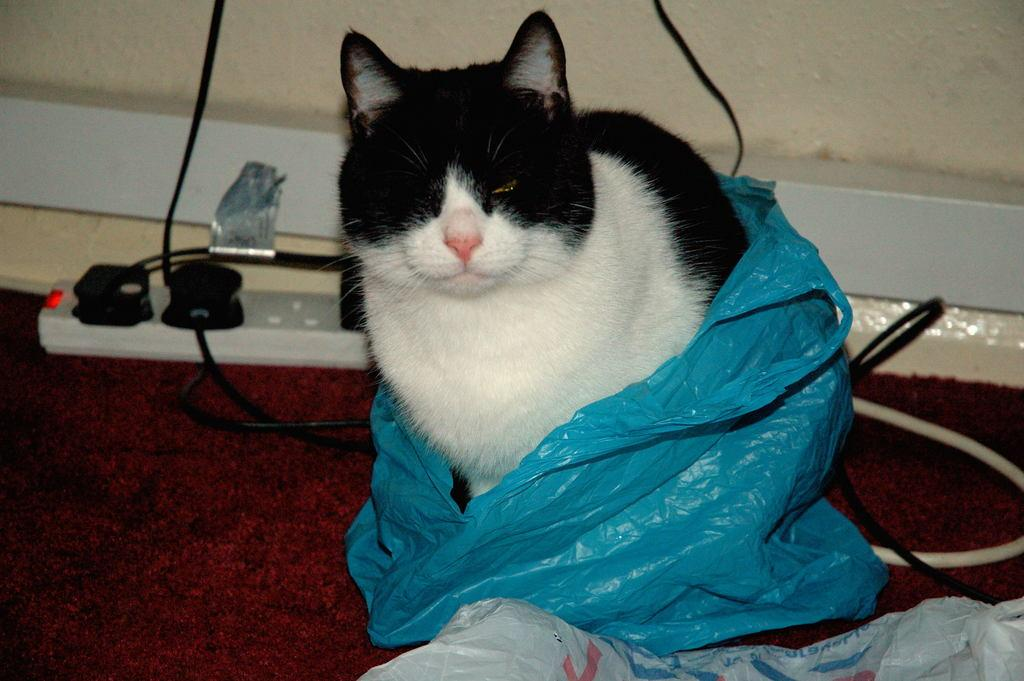What type of animal is in the image? There is a cat in the image. Can you describe the appearance of the cat? The cat is black and white in color. What is covering the cat in the image? There is a blue color cover in the image. What electrical device is visible in the image? An extension-board is visible in the image. What is connected to the extension-board? Wires are present in the image. What is the background of the image? There is a wall in the image. Are there any other objects in the image besides the cat and the electrical devices? Yes, there are other objects in the image. How many girls are expressing regret in the image? There are no girls or expressions of regret present in the image. 